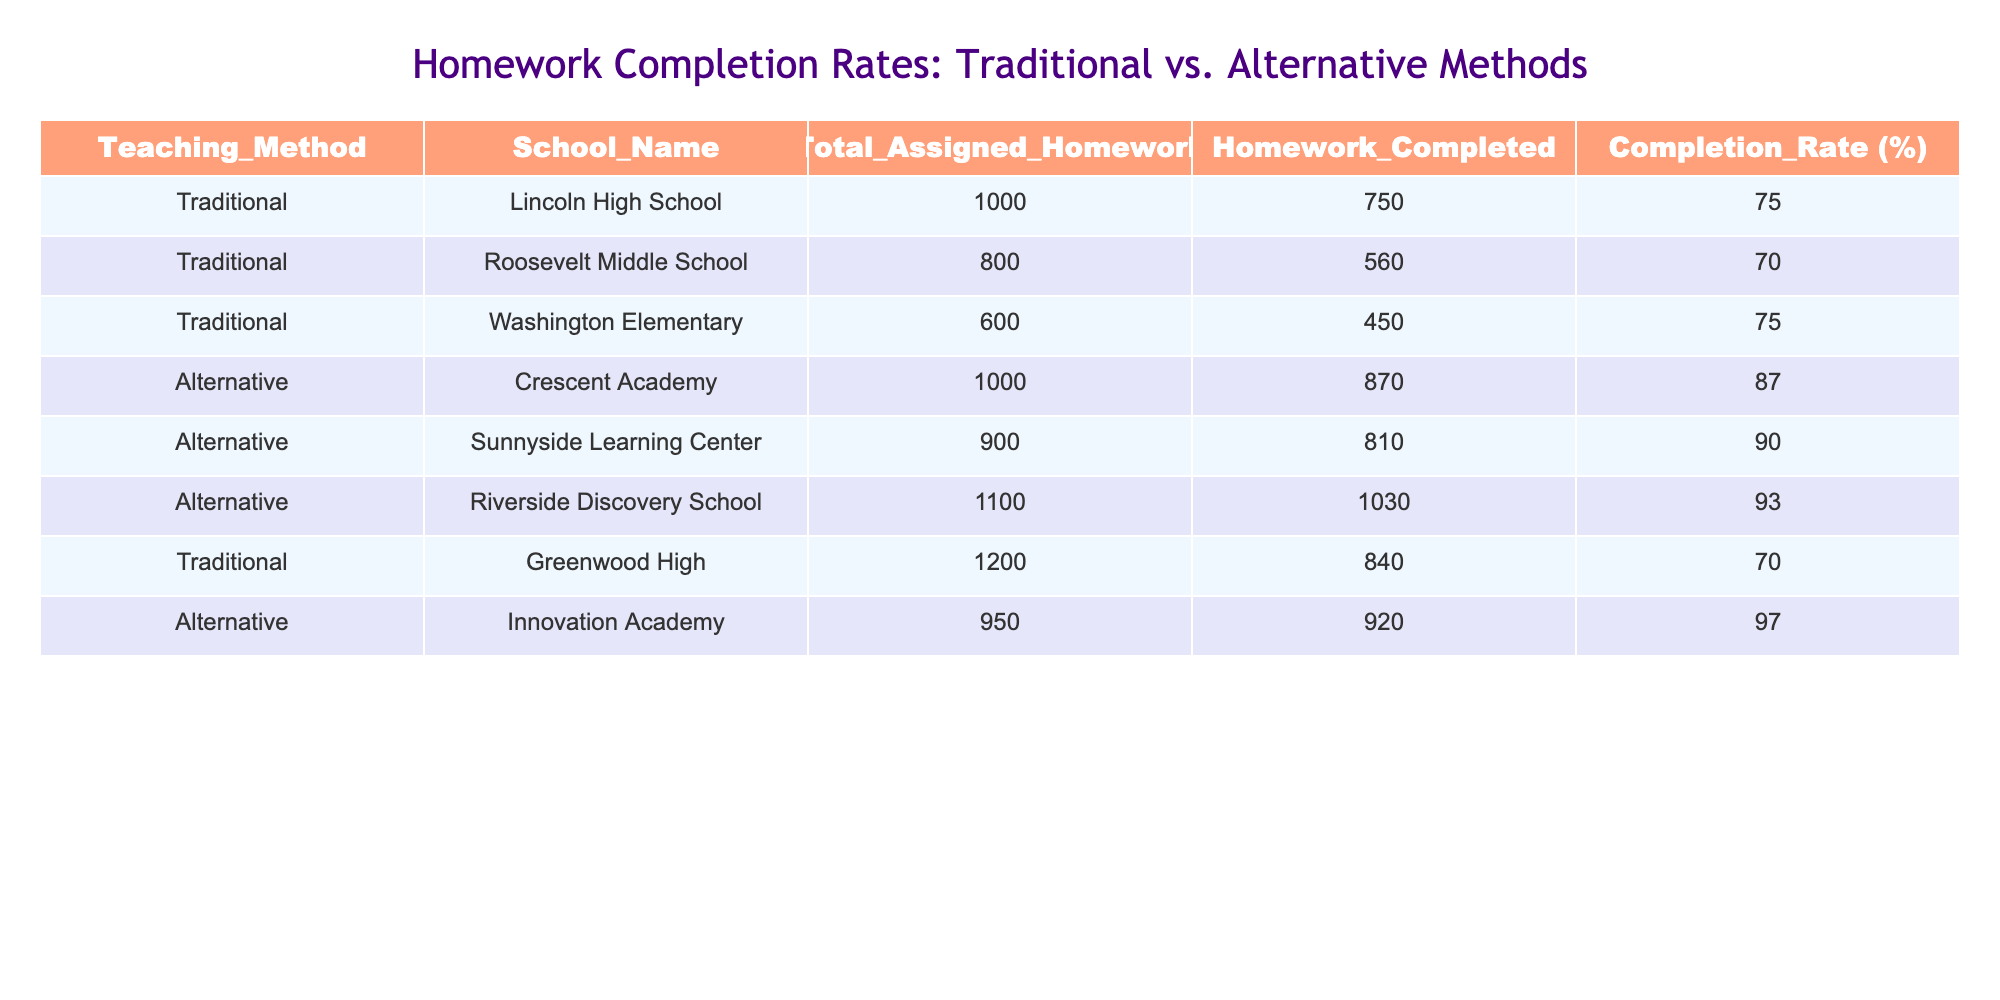What is the highest homework completion rate among alternative teaching methods? Looking at the alternative teaching methods, we can see the completion rates are 87%, 90%, 93%, and 97%. The highest among these is 97% at Innovation Academy.
Answer: 97% Which traditional school has the lowest homework completion rate? The completion rates for traditional schools are 75%, 70%, 75%, and 70%. The lowest completion rate is 70%, which occurs at Roosevelt Middle School and Greenwood High.
Answer: 70% What is the total amount of homework assigned in traditional schools? Adding the homework assigned for traditional schools (Lincoln: 1000, Roosevelt: 800, Washington: 600, Greenwood: 1200), we get 1000 + 800 + 600 + 1200 = 3600.
Answer: 3600 Are alternative teaching methods generally more effective in terms of homework completion rates compared to traditional methods? The overall average completion rates show alternatives at 91.5% (calculated by averaging the rates of alternative schools) and traditional at 73.75% (averaging traditional rates). Since 91.5% is higher than 73.75%, alternative methods are generally more effective.
Answer: Yes What is the difference in homework completion rates between the highest and lowest traditional schools? The highest traditional completion rate is 75% (Lincoln and Washington), and the lowest is 70% (Roosevelt and Greenwood). The difference is 75% - 70% = 5%.
Answer: 5% What percentage of homework was completed at Crescent Academy? The table indicates that Crescent Academy, under alternative methods, has a completion rate of 87%.
Answer: 87% How many more total homework assignments were given at Riverside Discovery School than at Roosevelt Middle School? For Riverside Discovery School (1100) and Roosevelt Middle School (800), we calculate the difference: 1100 - 800 = 300.
Answer: 300 Which school has the highest homework completion rate, and what is that rate? Comparing the completion rates, Riverside Discovery School has the highest rate at 93%.
Answer: 93% What is the average homework completion rate of all schools listed? To find the average, sum all completion rates (75 + 70 + 75 + 87 + 90 + 93 + 70 + 97), which totals 657. We then divide this by the number of schools (8): 657 / 8 = 82.125, rounded to 82% for simplicity.
Answer: 82% 